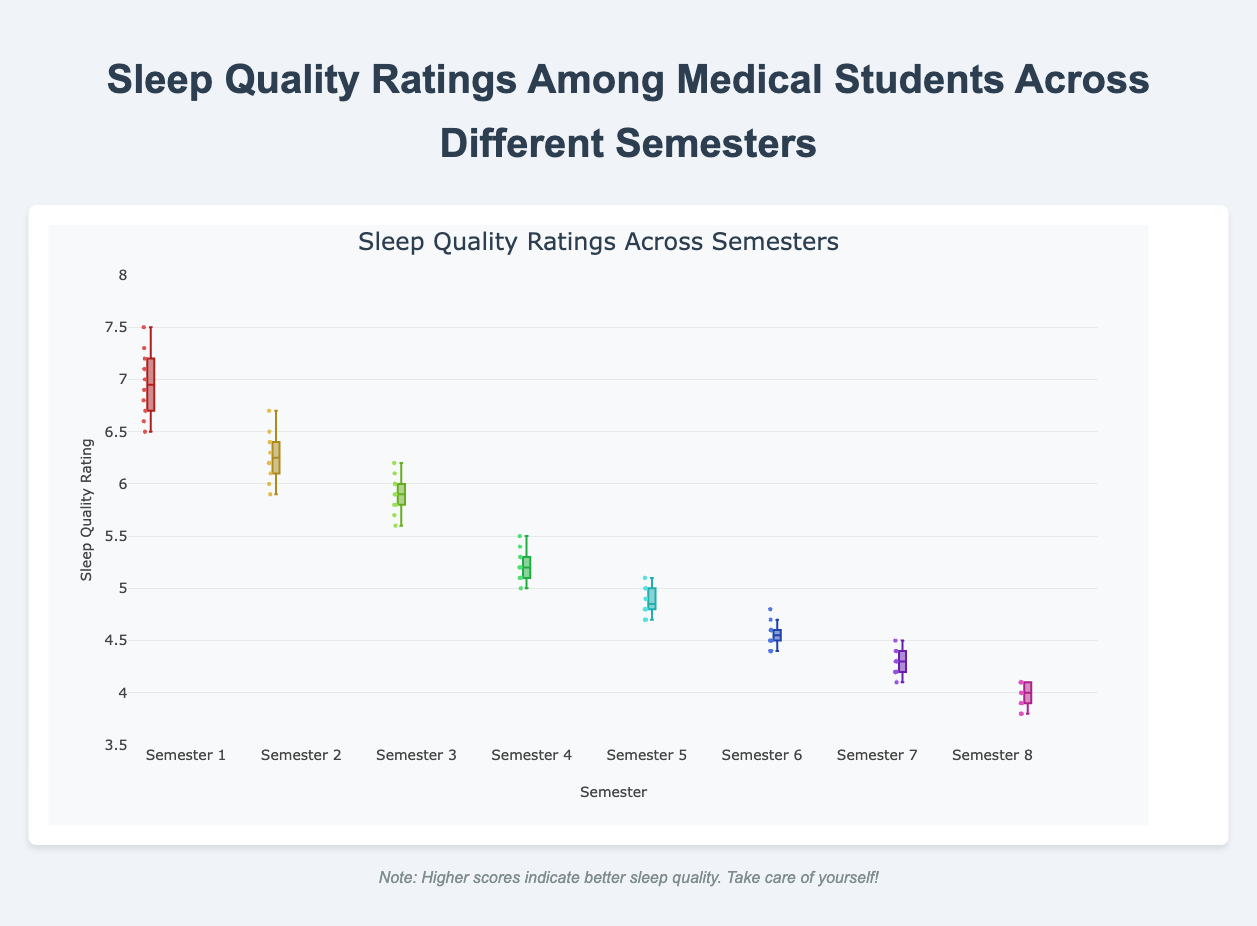What is the title of the figure? The title is located at the top of the figure and indicates what the data is about. It reads: "Sleep Quality Ratings Among Medical Students Across Different Semesters."
Answer: Sleep Quality Ratings Among Medical Students Across Different Semesters What is the sleep quality rating range shown on the y-axis? The y-axis displays the range of values for sleep quality ratings, and it ranges from 3.5 to 8.
Answer: 3.5 to 8 Which semester has the highest median sleep quality rating? The median value in a box plot is represented by the line inside the box. Among all semesters, Semester 1 has the highest median value.
Answer: Semester 1 Which semester has the lowest sleep quality rating and what is its value? The lowest value in a box plot is represented by the bottom whisker. The lowest value is for Semester 8, which is 3.8.
Answer: Semester 8, 3.8 How does the sleep quality rating change as students progress from Semester 1 to Semester 8? We can observe the general trend by looking at the median lines and the position of the boxes. The sleep quality rating decreases as students progress from Semester 1 to Semester 8.
Answer: It decreases Which semester has the largest interquartile range (IQR) for sleep quality ratings? The interquartile range (IQR) is the distance between the first and third quartiles (the edges of the box). By comparing the lengths, Semester 1 has the largest IQR.
Answer: Semester 1 How do the sleep quality ratings in Semester 6 compare to those in Semester 7? We look at the medians and the distribution of the ratings. The median sleep quality rating in Semester 6 is higher than in Semester 7, and the ratings in Semester 6 are more spread out.
Answer: Semester 6 is higher What is the median sleep quality rating for Semester 4? The median is represented by the line inside the box. For Semester 4, this line indicates the median value.
Answer: 5.2 Are there any outliers in the sleep quality ratings? Outliers in a box plot are typically represented by points outside the whiskers. This figure does not show any individual points outside the whiskers.
Answer: No Which semester shows the smallest variability in sleep quality ratings? The smallest variability is seen in the narrowest IQR and whiskers. Semester 8 shows the smallest variability.
Answer: Semester 8 